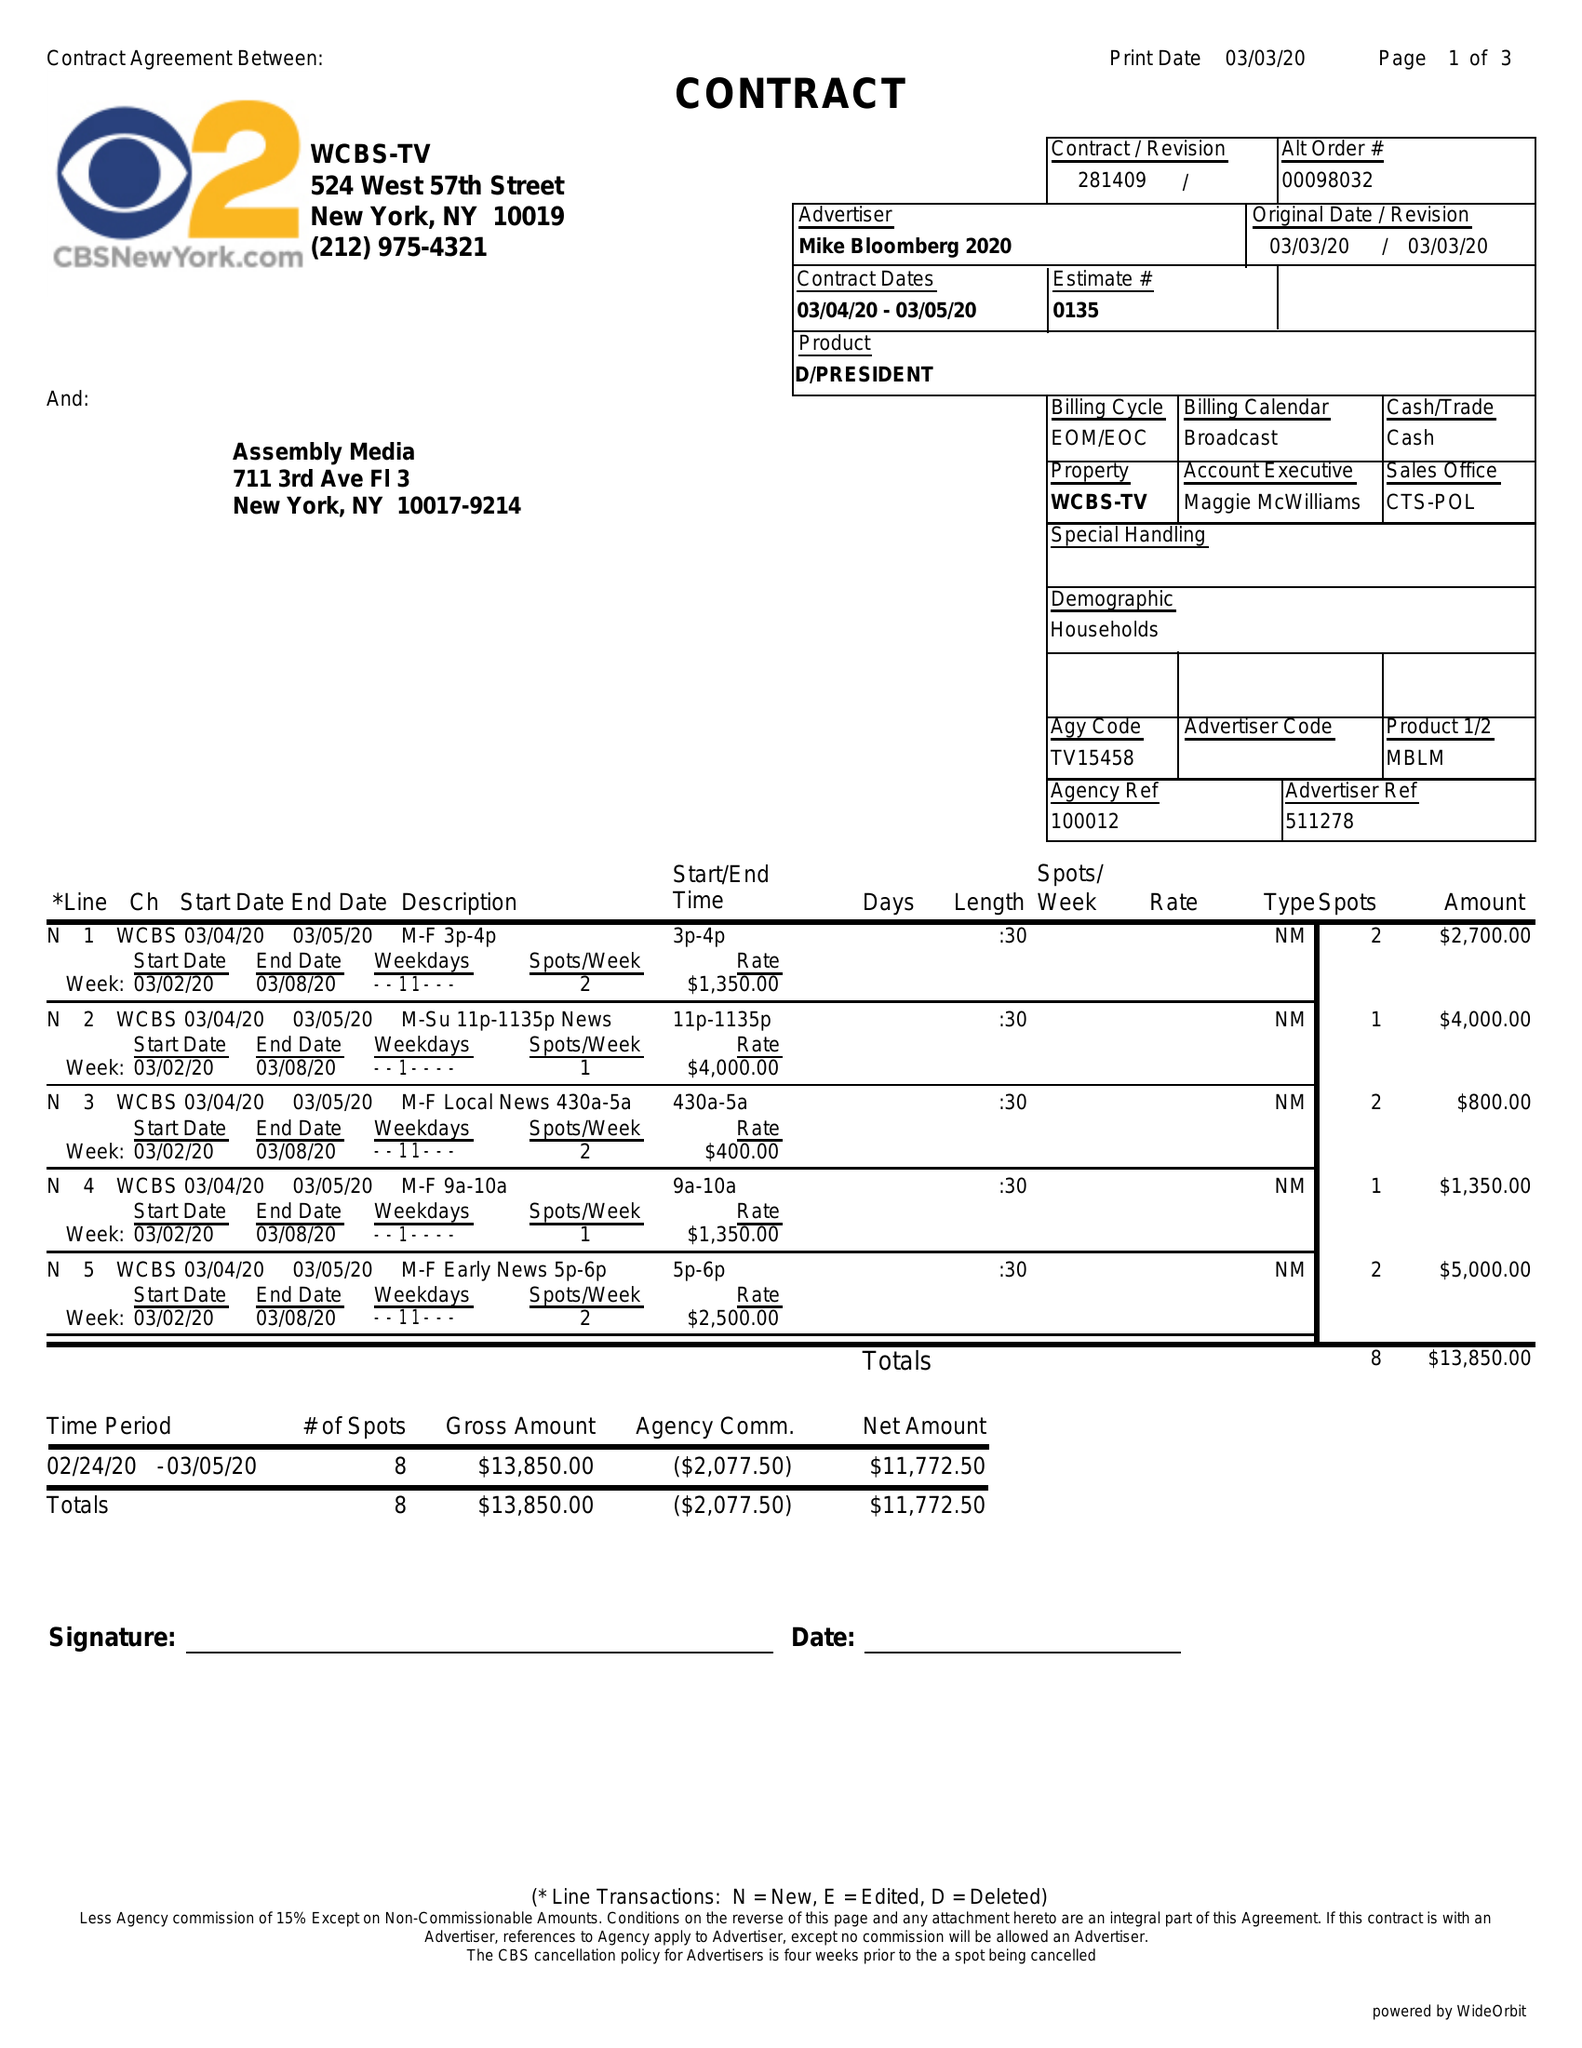What is the value for the flight_from?
Answer the question using a single word or phrase. 03/04/20 